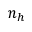Convert formula to latex. <formula><loc_0><loc_0><loc_500><loc_500>n _ { h }</formula> 